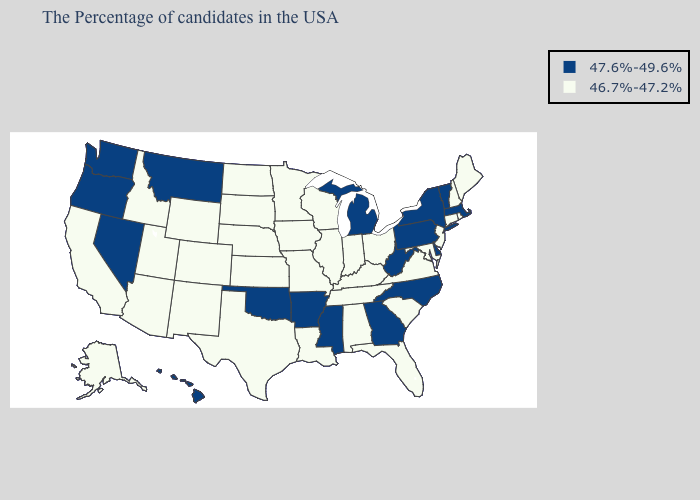Name the states that have a value in the range 46.7%-47.2%?
Answer briefly. Maine, Rhode Island, New Hampshire, Connecticut, New Jersey, Maryland, Virginia, South Carolina, Ohio, Florida, Kentucky, Indiana, Alabama, Tennessee, Wisconsin, Illinois, Louisiana, Missouri, Minnesota, Iowa, Kansas, Nebraska, Texas, South Dakota, North Dakota, Wyoming, Colorado, New Mexico, Utah, Arizona, Idaho, California, Alaska. Name the states that have a value in the range 46.7%-47.2%?
Answer briefly. Maine, Rhode Island, New Hampshire, Connecticut, New Jersey, Maryland, Virginia, South Carolina, Ohio, Florida, Kentucky, Indiana, Alabama, Tennessee, Wisconsin, Illinois, Louisiana, Missouri, Minnesota, Iowa, Kansas, Nebraska, Texas, South Dakota, North Dakota, Wyoming, Colorado, New Mexico, Utah, Arizona, Idaho, California, Alaska. Name the states that have a value in the range 46.7%-47.2%?
Concise answer only. Maine, Rhode Island, New Hampshire, Connecticut, New Jersey, Maryland, Virginia, South Carolina, Ohio, Florida, Kentucky, Indiana, Alabama, Tennessee, Wisconsin, Illinois, Louisiana, Missouri, Minnesota, Iowa, Kansas, Nebraska, Texas, South Dakota, North Dakota, Wyoming, Colorado, New Mexico, Utah, Arizona, Idaho, California, Alaska. What is the lowest value in the USA?
Concise answer only. 46.7%-47.2%. Among the states that border Colorado , does Arizona have the highest value?
Concise answer only. No. Does the first symbol in the legend represent the smallest category?
Be succinct. No. Name the states that have a value in the range 47.6%-49.6%?
Be succinct. Massachusetts, Vermont, New York, Delaware, Pennsylvania, North Carolina, West Virginia, Georgia, Michigan, Mississippi, Arkansas, Oklahoma, Montana, Nevada, Washington, Oregon, Hawaii. Name the states that have a value in the range 46.7%-47.2%?
Keep it brief. Maine, Rhode Island, New Hampshire, Connecticut, New Jersey, Maryland, Virginia, South Carolina, Ohio, Florida, Kentucky, Indiana, Alabama, Tennessee, Wisconsin, Illinois, Louisiana, Missouri, Minnesota, Iowa, Kansas, Nebraska, Texas, South Dakota, North Dakota, Wyoming, Colorado, New Mexico, Utah, Arizona, Idaho, California, Alaska. Does Iowa have the lowest value in the MidWest?
Concise answer only. Yes. What is the highest value in states that border Kansas?
Be succinct. 47.6%-49.6%. Which states have the highest value in the USA?
Be succinct. Massachusetts, Vermont, New York, Delaware, Pennsylvania, North Carolina, West Virginia, Georgia, Michigan, Mississippi, Arkansas, Oklahoma, Montana, Nevada, Washington, Oregon, Hawaii. Which states have the lowest value in the South?
Answer briefly. Maryland, Virginia, South Carolina, Florida, Kentucky, Alabama, Tennessee, Louisiana, Texas. What is the value of Colorado?
Write a very short answer. 46.7%-47.2%. Name the states that have a value in the range 46.7%-47.2%?
Keep it brief. Maine, Rhode Island, New Hampshire, Connecticut, New Jersey, Maryland, Virginia, South Carolina, Ohio, Florida, Kentucky, Indiana, Alabama, Tennessee, Wisconsin, Illinois, Louisiana, Missouri, Minnesota, Iowa, Kansas, Nebraska, Texas, South Dakota, North Dakota, Wyoming, Colorado, New Mexico, Utah, Arizona, Idaho, California, Alaska. Does Ohio have a higher value than North Carolina?
Answer briefly. No. 